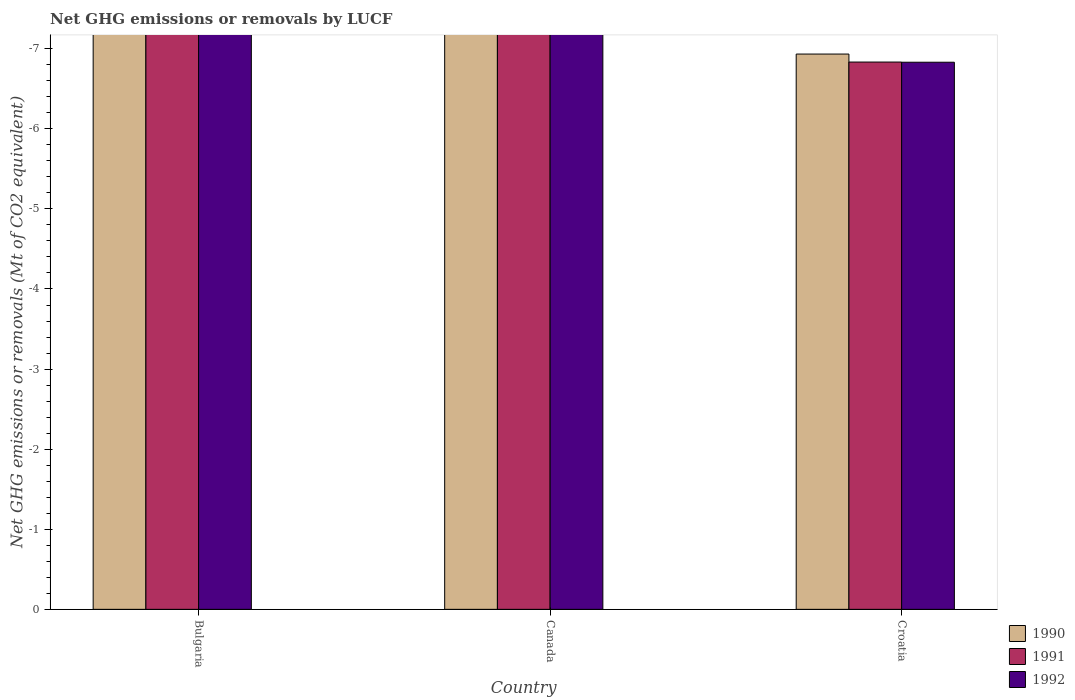Are the number of bars per tick equal to the number of legend labels?
Offer a very short reply. No. How many bars are there on the 3rd tick from the right?
Your answer should be compact. 0. What is the label of the 3rd group of bars from the left?
Give a very brief answer. Croatia. In how many cases, is the number of bars for a given country not equal to the number of legend labels?
Your answer should be very brief. 3. What is the net GHG emissions or removals by LUCF in 1991 in Croatia?
Offer a terse response. 0. What is the total net GHG emissions or removals by LUCF in 1992 in the graph?
Ensure brevity in your answer.  0. In how many countries, is the net GHG emissions or removals by LUCF in 1990 greater than -3.2 Mt?
Your response must be concise. 0. How many countries are there in the graph?
Make the answer very short. 3. Are the values on the major ticks of Y-axis written in scientific E-notation?
Your answer should be very brief. No. Does the graph contain any zero values?
Keep it short and to the point. Yes. What is the title of the graph?
Provide a succinct answer. Net GHG emissions or removals by LUCF. Does "1963" appear as one of the legend labels in the graph?
Make the answer very short. No. What is the label or title of the X-axis?
Make the answer very short. Country. What is the label or title of the Y-axis?
Give a very brief answer. Net GHG emissions or removals (Mt of CO2 equivalent). What is the Net GHG emissions or removals (Mt of CO2 equivalent) in 1990 in Bulgaria?
Give a very brief answer. 0. What is the Net GHG emissions or removals (Mt of CO2 equivalent) in 1991 in Bulgaria?
Your answer should be very brief. 0. What is the Net GHG emissions or removals (Mt of CO2 equivalent) in 1990 in Canada?
Your response must be concise. 0. What is the Net GHG emissions or removals (Mt of CO2 equivalent) in 1991 in Canada?
Ensure brevity in your answer.  0. What is the Net GHG emissions or removals (Mt of CO2 equivalent) in 1992 in Canada?
Provide a short and direct response. 0. What is the Net GHG emissions or removals (Mt of CO2 equivalent) of 1991 in Croatia?
Make the answer very short. 0. What is the Net GHG emissions or removals (Mt of CO2 equivalent) in 1992 in Croatia?
Keep it short and to the point. 0. What is the total Net GHG emissions or removals (Mt of CO2 equivalent) in 1991 in the graph?
Make the answer very short. 0. 